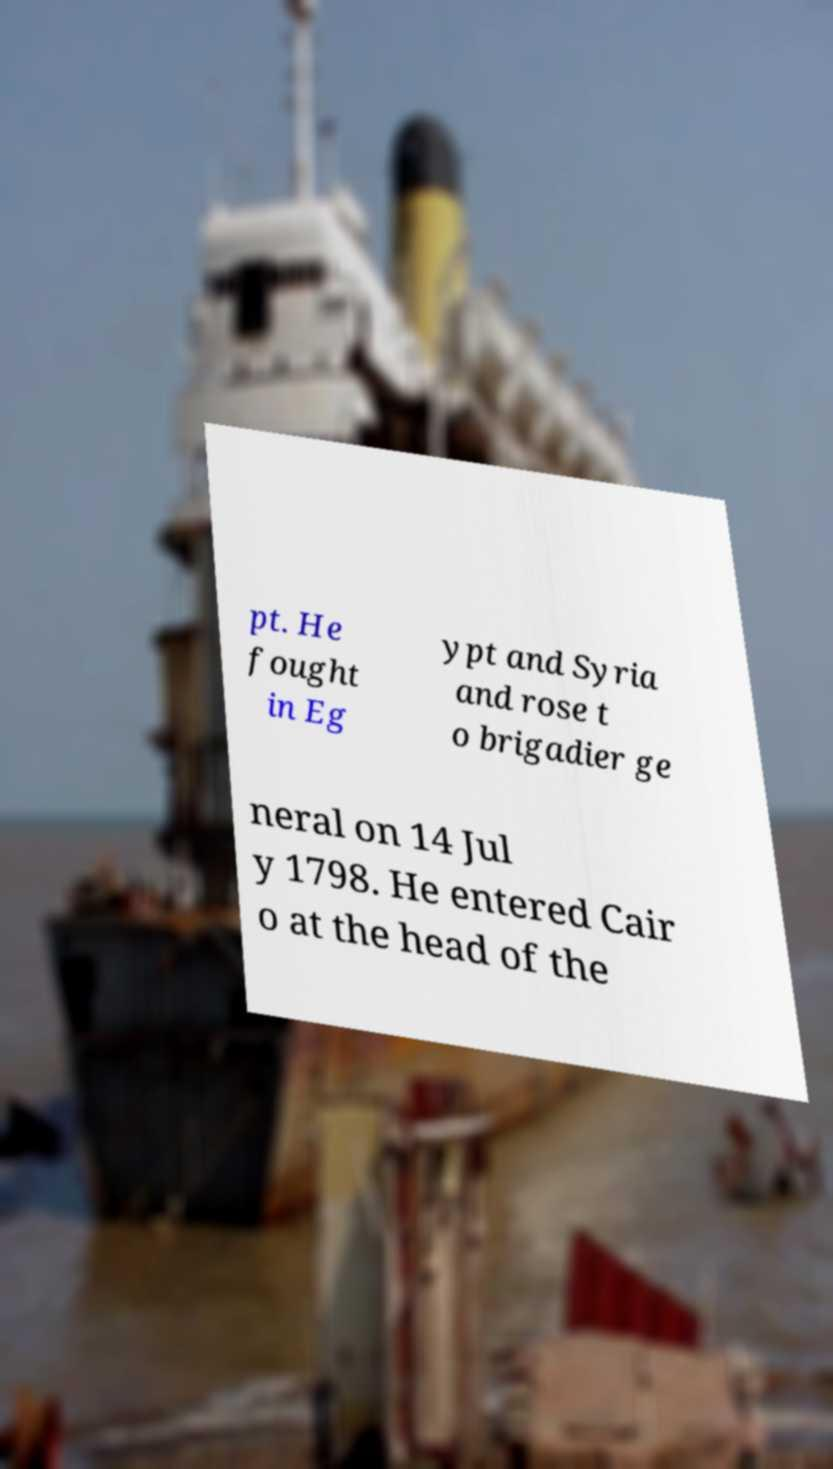There's text embedded in this image that I need extracted. Can you transcribe it verbatim? pt. He fought in Eg ypt and Syria and rose t o brigadier ge neral on 14 Jul y 1798. He entered Cair o at the head of the 